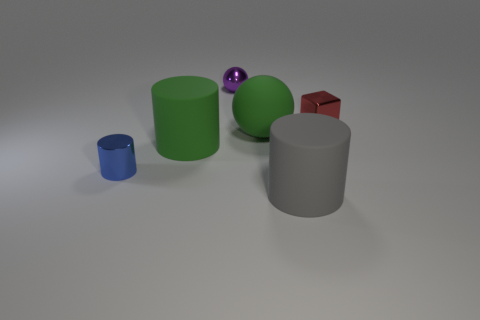Add 3 big metal cubes. How many objects exist? 9 Subtract all blocks. How many objects are left? 5 Subtract all large brown matte objects. Subtract all large objects. How many objects are left? 3 Add 1 large gray things. How many large gray things are left? 2 Add 5 matte things. How many matte things exist? 8 Subtract 1 purple spheres. How many objects are left? 5 